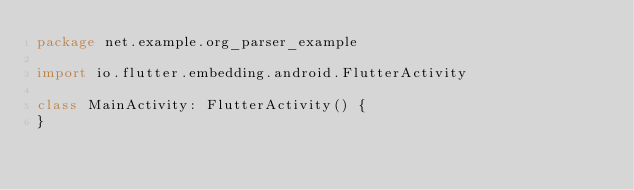Convert code to text. <code><loc_0><loc_0><loc_500><loc_500><_Kotlin_>package net.example.org_parser_example

import io.flutter.embedding.android.FlutterActivity

class MainActivity: FlutterActivity() {
}
</code> 